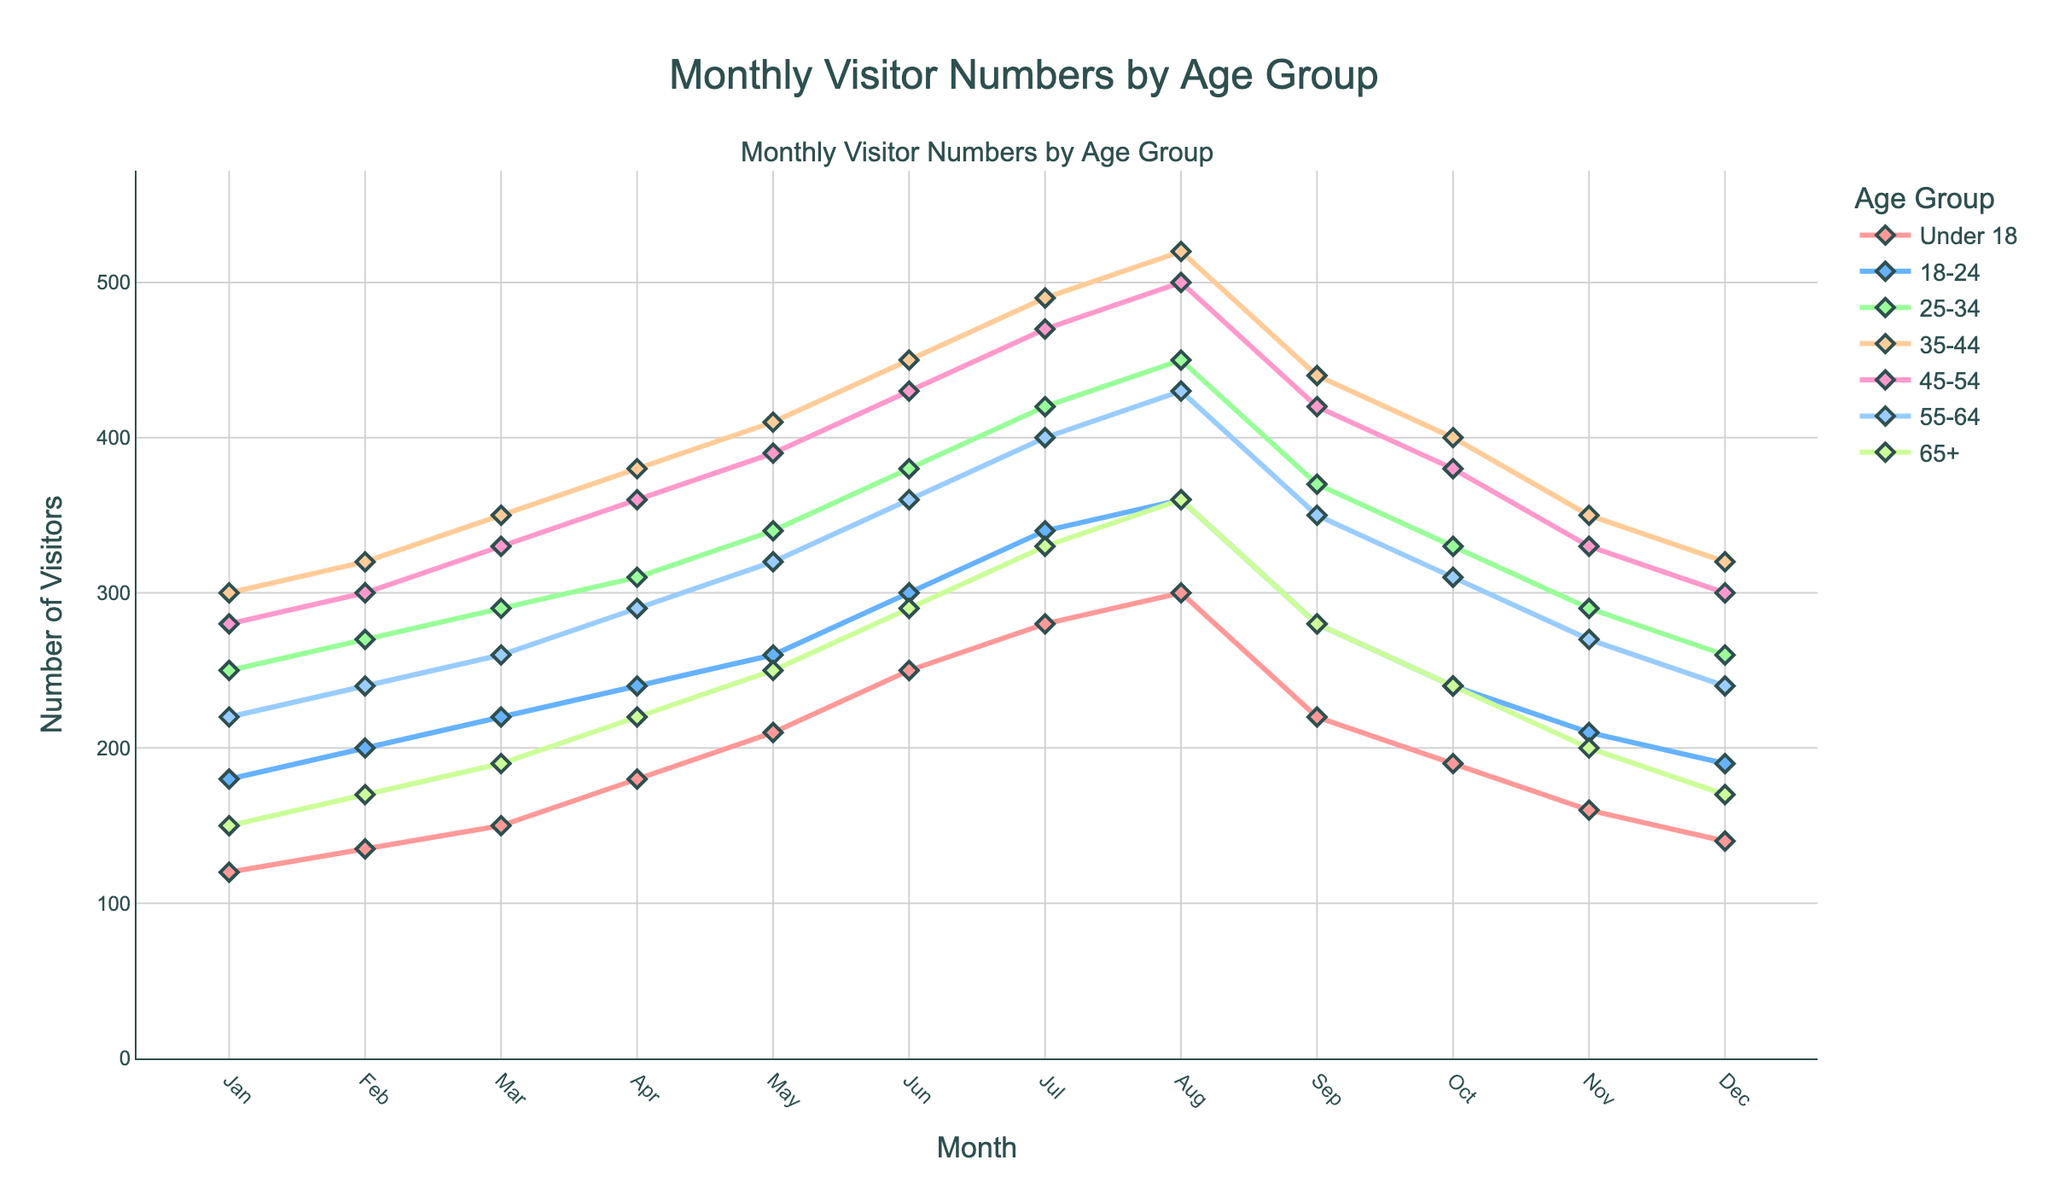What is the overall trend in the number of visitors across all age groups from January to December? The overall trend shows an increase in visitor numbers for all age groups from January to the peak in August, followed by a decrease towards December.
Answer: Increase until August, then decrease Which age group has the highest number of visitors in August? By looking at the peak values for August, the 35-44 age group has the highest number of visitors.
Answer: 35-44 Compare the number of visitors for the 18-24 and 25-34 age groups in March. Which group has more visitors? In March, the 18-24 age group has 220 visitors, whereas the 25-34 age group has 290 visitors. Therefore, the 25-34 age group has more visitors.
Answer: 25-34 What is the average number of visitors for the 45-54 age group from January to December? Summing the monthly visitors for the 45-54 age group gives 4,510. Dividing this by 12 months results in an average of 375.83 visitors.
Answer: 375.83 Identify the month with the lowest number of visitors for the 55-64 age group. By looking at the lowest point in the 55-64 age group’s line, the lowest number of visitors is in January, with 220 visitors.
Answer: January How does the number of visitors for the 65+ age group in June compare to that in September? In June, the 65+ age group has 290 visitors, while in September, the number drops to 280 visitors. Thus, there is a decrease.
Answer: Lower in September What is the median number of visitors for the Under 18 age group? The monthly visitor numbers for Under 18 are [120, 135, 150, 180, 210, 250, 280, 300, 220, 190, 160, 140]. Arranging these and finding the median of the ordered sequence gives the median number 185.
Answer: 185 Which two age groups show the most similar trends in visitor numbers over the year? By visually comparing the lines, the 35-44 and 45-54 age groups' trends are most similar, showing a consistent increase and decrease pattern.
Answer: 35-44 and 45-54 Calculate the total number of visitors across all age groups in July. Summing the visitor numbers in July for all age groups: 280 (Under 18) + 340 (18-24) + 420 (25-34) + 490 (35-44) + 470 (45-54) + 400 (55-64) + 330 (65+). This totals 2,730.
Answer: 2,730 Between which two consecutive months is the largest increase in visitors for the 25-34 age group? Comparing the increases month over month for the 25-34 age group, the largest increase is from June to July (380 to 420).
Answer: June to July 